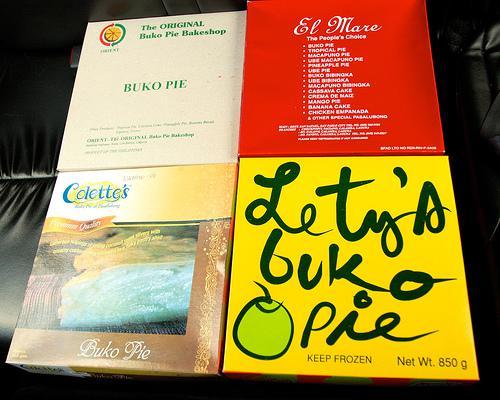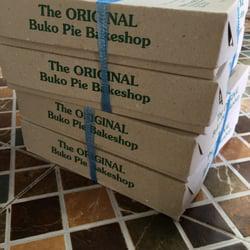The first image is the image on the left, the second image is the image on the right. Evaluate the accuracy of this statement regarding the images: "In at least one image there is a bunko pie missing at least one slice.". Is it true? Answer yes or no. No. The first image is the image on the left, the second image is the image on the right. Analyze the images presented: Is the assertion "A pie is in an open box." valid? Answer yes or no. No. 